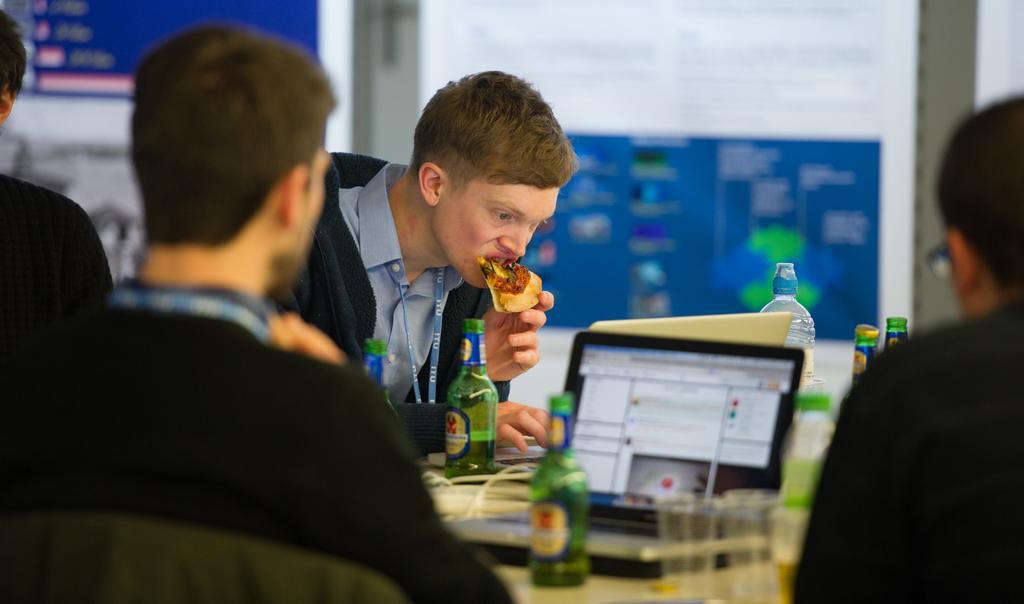How would you summarize this image in a sentence or two? In this picture we can see a group of people and one person is holding food, in front of them we can see laptops, bottles and in the background we can see a wall and some objects. 